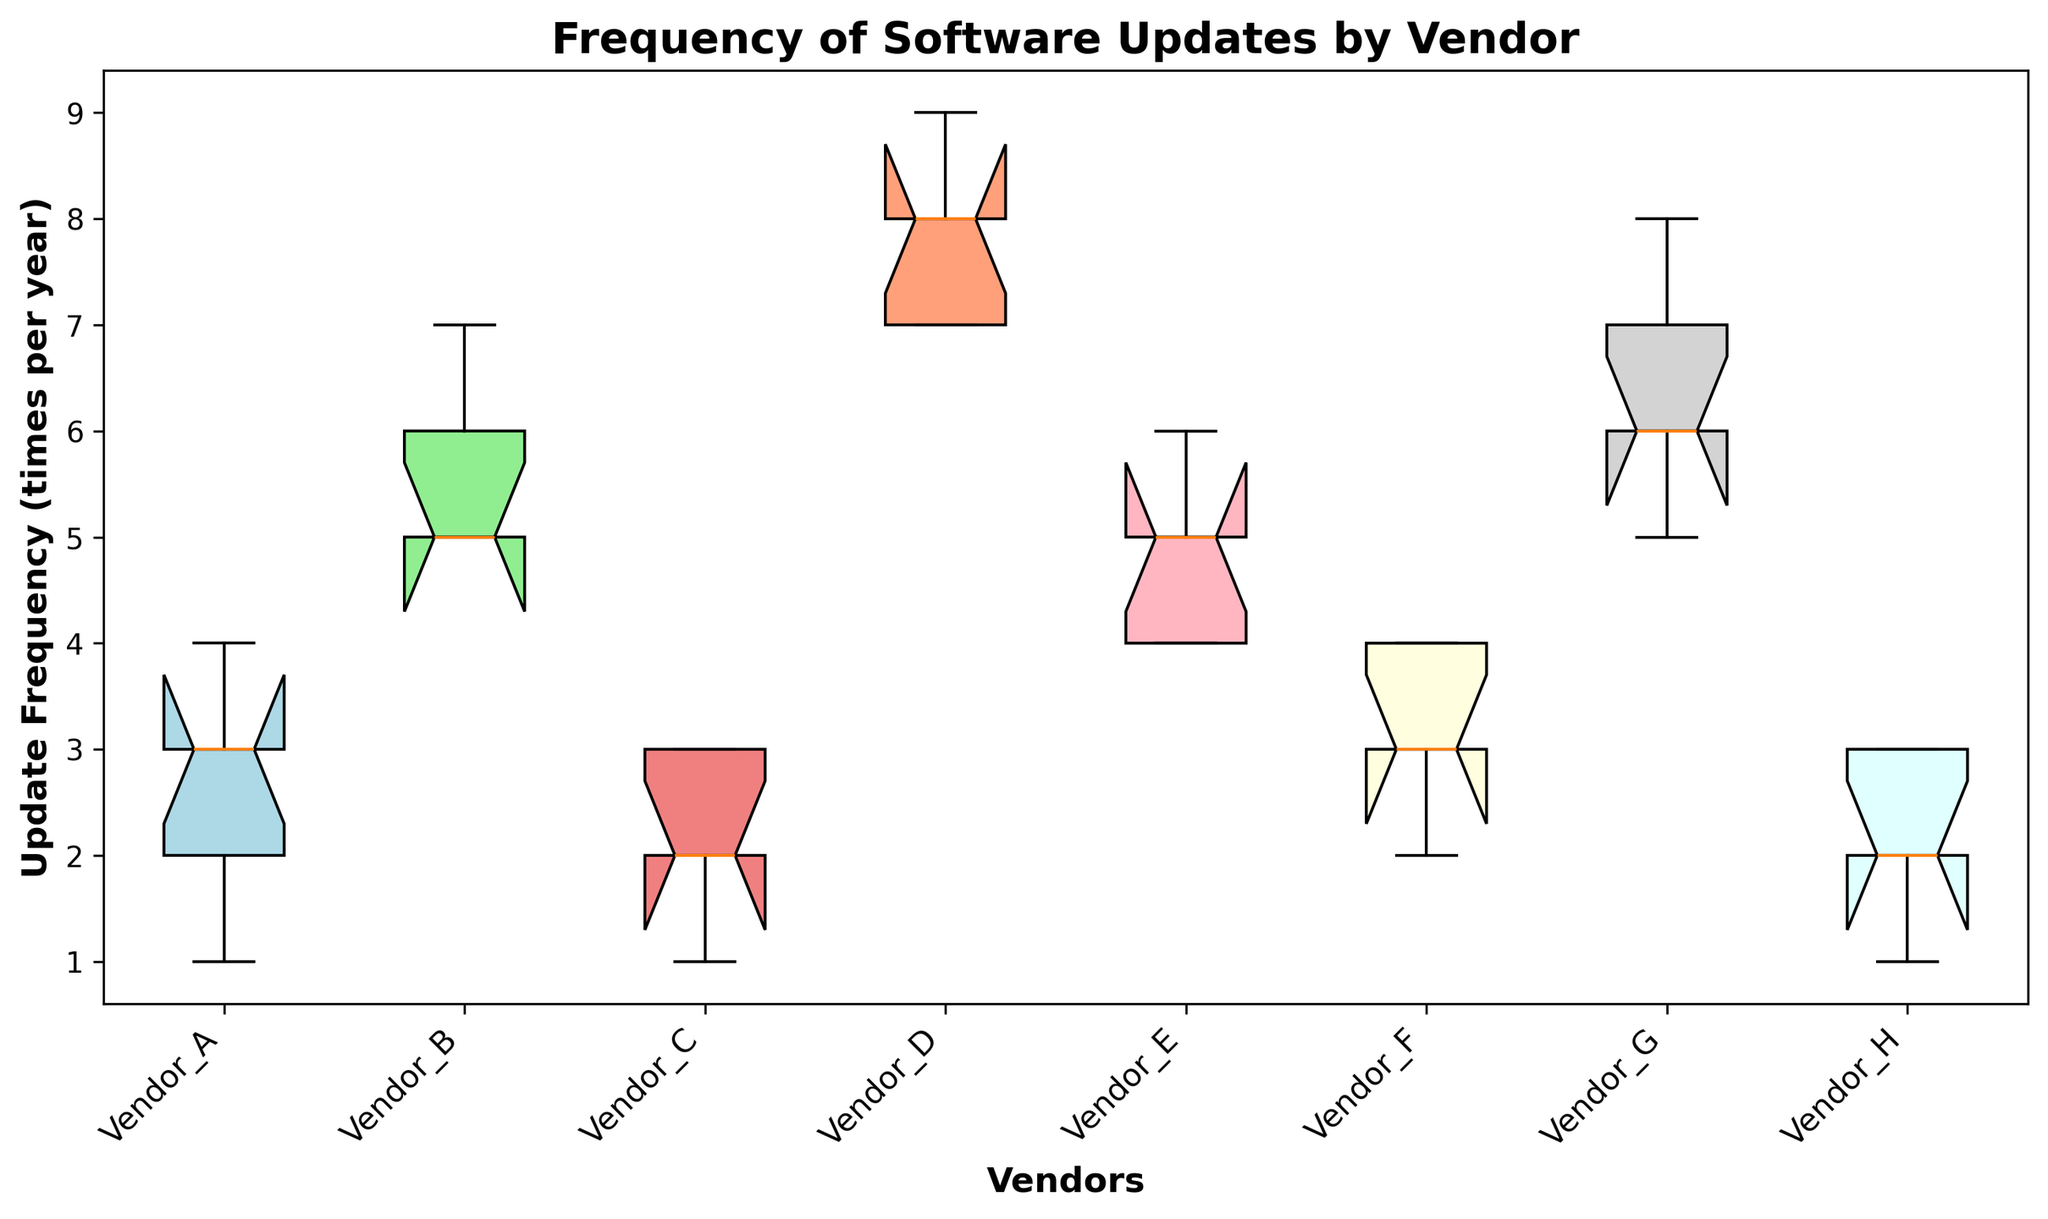What's the median update frequency for Vendor B? The median is the middle value in an ordered list. Sorting Vendor B's values (5, 5, 5, 6, 7), the median value is 5.
Answer: 5 Which vendor has the highest median update frequency? To find the highest median, compare the medians of all vendors. Vendor D has the highest median with a value of 8.
Answer: Vendor D Which vendor requires the most frequent updates on average? Calculate the average update frequency for each vendor and compare them. Vendor D has the highest average frequency.
Answer: Vendor D Which vendor has the least variation in update frequency? The least variation is represented by the shortest box in the box plot. Vendor H has the smallest box with the least variation.
Answer: Vendor H What is the interquartile range (IQR) for Vendor G? IQR is the difference between the 75th percentile (Q3) and 25th percentile (Q1). In the box plot for Vendor G, Q3 is 7 and Q1 is 5, so IQR = 7 - 5 = 2.
Answer: 2 Compare the median update frequencies of Vendor A and Vendor E. Which one is higher? Compare the two medians directly from the box plot. Vendor E has a median of 5, while Vendor A has a median of 3. Vendor E's median is higher.
Answer: Vendor E Which vendor(s) have outliers in their update frequency data? Outliers are points that are beyond the whiskers of the box plot. Vendor D has outliers as represented by the points beyond the whiskers.
Answer: Vendor D Which vendor has the broadest range of update frequencies? The range is the difference between the maximum and minimum values. Vendor D, with values from 7 to 9, has the broadest range (2) in the box plot.
Answer: Vendor D Which vendors, if any, have the same median update frequency? Identifying vendors with the same median from the box plot reveals that Vendors A and C both have a median update frequency of 2.
Answer: Vendors A and C 